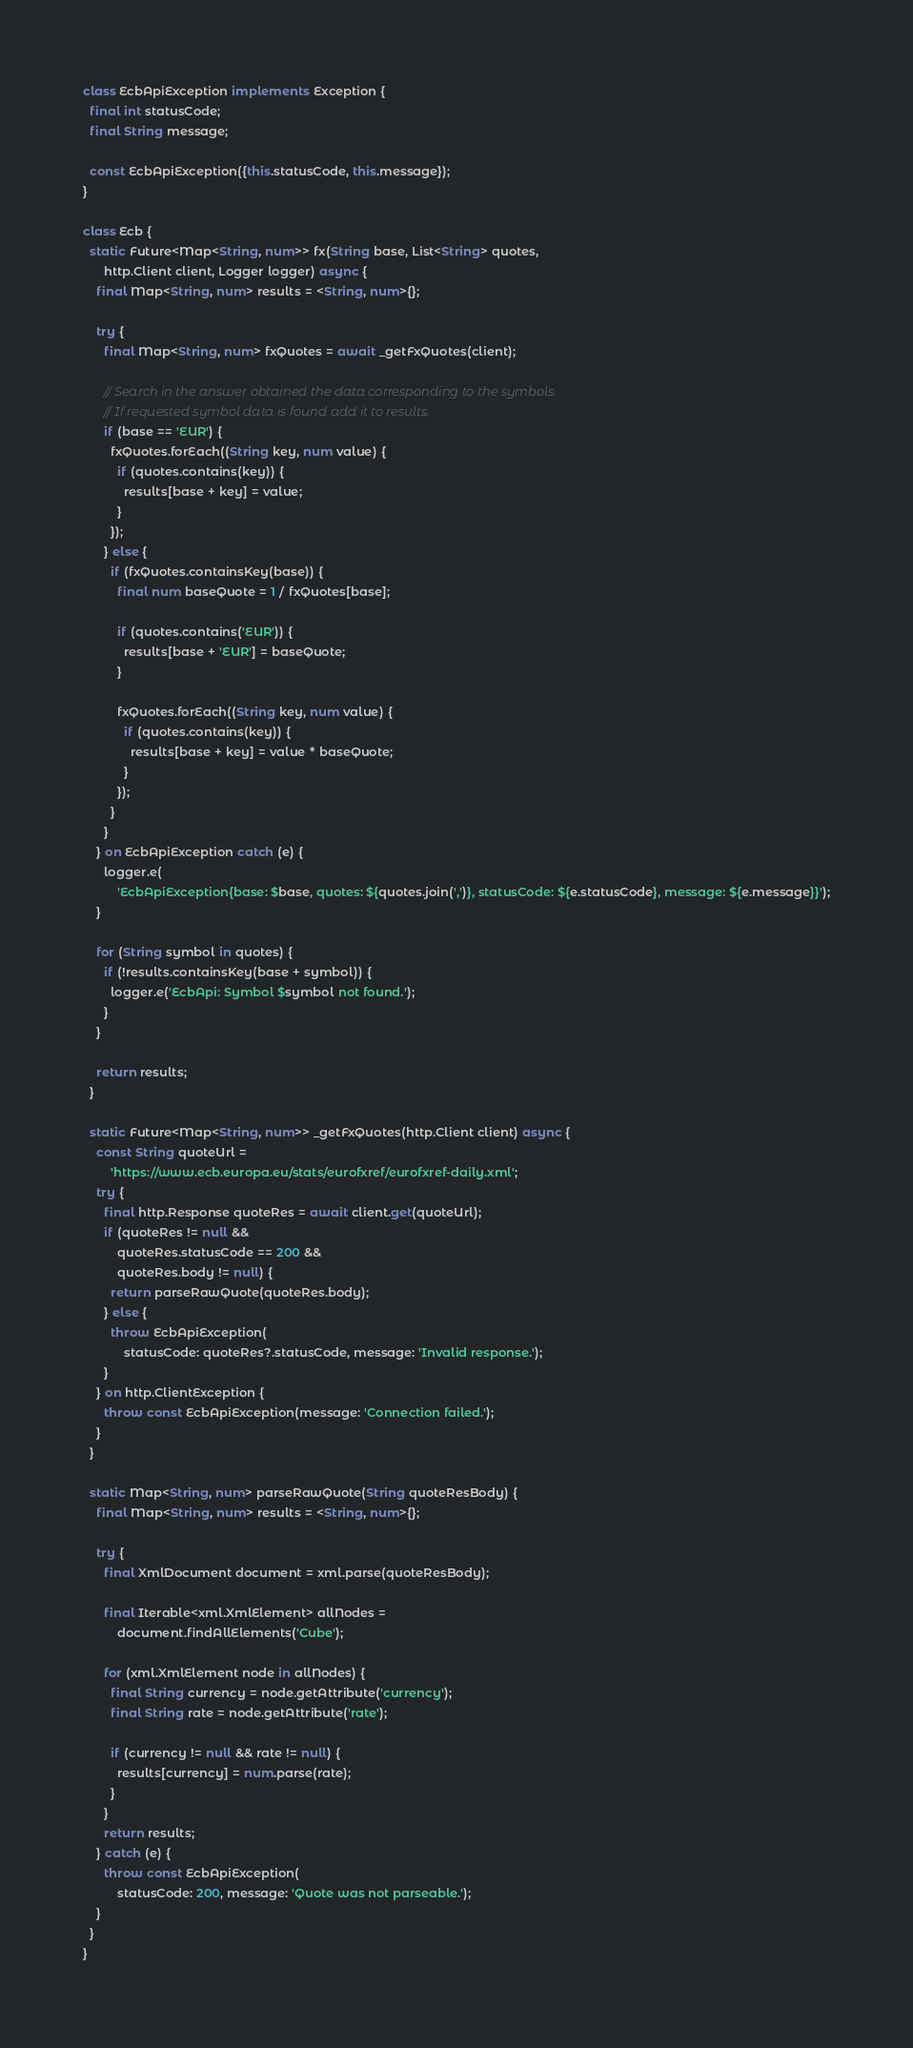<code> <loc_0><loc_0><loc_500><loc_500><_Dart_>class EcbApiException implements Exception {
  final int statusCode;
  final String message;

  const EcbApiException({this.statusCode, this.message});
}

class Ecb {
  static Future<Map<String, num>> fx(String base, List<String> quotes,
      http.Client client, Logger logger) async {
    final Map<String, num> results = <String, num>{};

    try {
      final Map<String, num> fxQuotes = await _getFxQuotes(client);

      // Search in the answer obtained the data corresponding to the symbols.
      // If requested symbol data is found add it to results.
      if (base == 'EUR') {
        fxQuotes.forEach((String key, num value) {
          if (quotes.contains(key)) {
            results[base + key] = value;
          }
        });
      } else {
        if (fxQuotes.containsKey(base)) {
          final num baseQuote = 1 / fxQuotes[base];

          if (quotes.contains('EUR')) {
            results[base + 'EUR'] = baseQuote;
          }

          fxQuotes.forEach((String key, num value) {
            if (quotes.contains(key)) {
              results[base + key] = value * baseQuote;
            }
          });
        }
      }
    } on EcbApiException catch (e) {
      logger.e(
          'EcbApiException{base: $base, quotes: ${quotes.join(',')}, statusCode: ${e.statusCode}, message: ${e.message}}');
    }

    for (String symbol in quotes) {
      if (!results.containsKey(base + symbol)) {
        logger.e('EcbApi: Symbol $symbol not found.');
      }
    }

    return results;
  }

  static Future<Map<String, num>> _getFxQuotes(http.Client client) async {
    const String quoteUrl =
        'https://www.ecb.europa.eu/stats/eurofxref/eurofxref-daily.xml';
    try {
      final http.Response quoteRes = await client.get(quoteUrl);
      if (quoteRes != null &&
          quoteRes.statusCode == 200 &&
          quoteRes.body != null) {
        return parseRawQuote(quoteRes.body);
      } else {
        throw EcbApiException(
            statusCode: quoteRes?.statusCode, message: 'Invalid response.');
      }
    } on http.ClientException {
      throw const EcbApiException(message: 'Connection failed.');
    }
  }

  static Map<String, num> parseRawQuote(String quoteResBody) {
    final Map<String, num> results = <String, num>{};

    try {
      final XmlDocument document = xml.parse(quoteResBody);

      final Iterable<xml.XmlElement> allNodes =
          document.findAllElements('Cube');

      for (xml.XmlElement node in allNodes) {
        final String currency = node.getAttribute('currency');
        final String rate = node.getAttribute('rate');

        if (currency != null && rate != null) {
          results[currency] = num.parse(rate);
        }
      }
      return results;
    } catch (e) {
      throw const EcbApiException(
          statusCode: 200, message: 'Quote was not parseable.');
    }
  }
}
</code> 